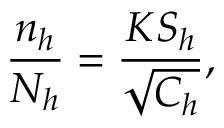<formula> <loc_0><loc_0><loc_500><loc_500>{ \frac { n _ { h } } { N _ { h } } } = { \frac { K S _ { h } } { \sqrt { C _ { h } } } } ,</formula> 